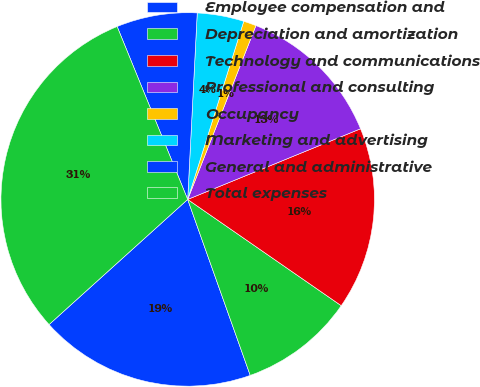<chart> <loc_0><loc_0><loc_500><loc_500><pie_chart><fcel>Employee compensation and<fcel>Depreciation and amortization<fcel>Technology and communications<fcel>Professional and consulting<fcel>Occupancy<fcel>Marketing and advertising<fcel>General and administrative<fcel>Total expenses<nl><fcel>18.75%<fcel>9.93%<fcel>15.81%<fcel>12.87%<fcel>1.1%<fcel>4.04%<fcel>6.98%<fcel>30.52%<nl></chart> 